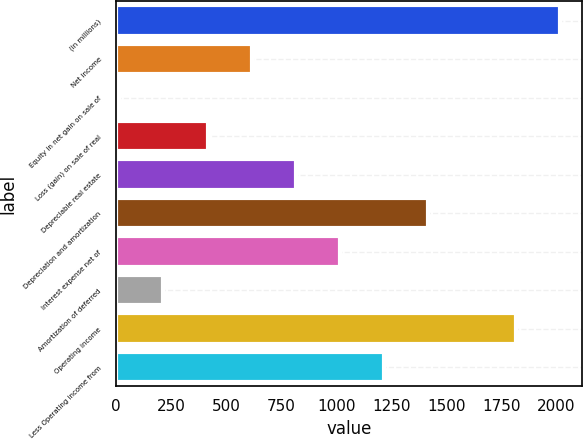Convert chart to OTSL. <chart><loc_0><loc_0><loc_500><loc_500><bar_chart><fcel>(in millions)<fcel>Net income<fcel>Equity in net gain on sale of<fcel>Loss (gain) on sale of real<fcel>Depreciable real estate<fcel>Depreciation and amortization<fcel>Interest expense net of<fcel>Amortization of deferred<fcel>Operating income<fcel>Less Operating income from<nl><fcel>2017<fcel>616.44<fcel>16.2<fcel>416.36<fcel>816.52<fcel>1416.76<fcel>1016.6<fcel>216.28<fcel>1816.92<fcel>1216.68<nl></chart> 